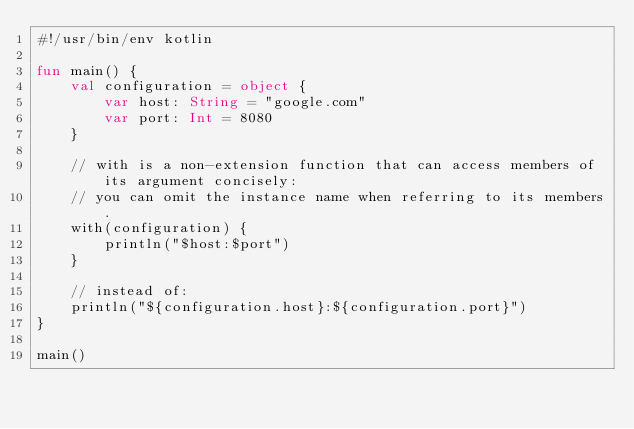Convert code to text. <code><loc_0><loc_0><loc_500><loc_500><_Kotlin_>#!/usr/bin/env kotlin

fun main() {
    val configuration = object {
        var host: String = "google.com"
        var port: Int = 8080
    }

    // with is a non-extension function that can access members of its argument concisely:
    // you can omit the instance name when referring to its members.
    with(configuration) {
        println("$host:$port")
    }

    // instead of:
    println("${configuration.host}:${configuration.port}")
}

main()
</code> 